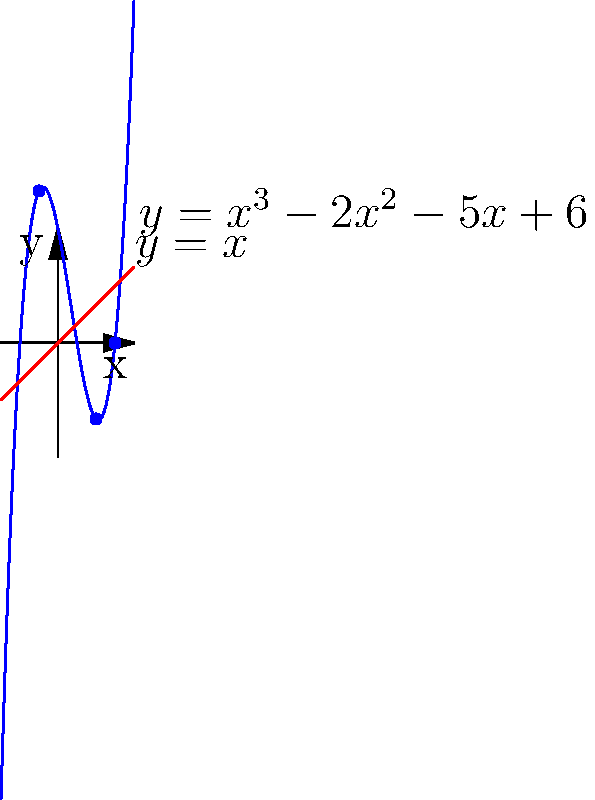Consider the polynomial $f(x) = x^3 - 2x^2 - 5x + 6$ graphed in blue, and the line $y = x$ graphed in red. Which graphical method for finding roots is represented here, and what are the approximate roots of $f(x)$? To answer this question, let's follow these steps:

1) The graphical method represented here is the intersection method. This method finds the roots of a polynomial by identifying the points where the graph of the polynomial intersects with the line $y = x$.

2) The roots of $f(x)$ are the $x$-coordinates of the points where $f(x) = x$, which are visually represented by the intersections of the blue curve (polynomial) and the red line ($y = x$).

3) From the graph, we can see three intersection points:
   - One near $x = -1$
   - One near $x = 2$
   - One near $x = 3$

4) These intersection points represent the approximate roots of the polynomial $f(x) = x^3 - 2x^2 - 5x + 6$.

5) The exact roots could be found algebraically by solving the equation $x^3 - 2x^2 - 5x + 6 = x$, or equivalently, $x^3 - 2x^2 - 6x + 6 = 0$. However, the question asks for the graphical method and approximate roots.

6) This method is particularly useful in algebraic geometry and scheme theory as it provides a visual representation of the zeros of polynomials, which correspond to points on algebraic varieties.
Answer: Intersection method; roots approximately at $x = -1, 2, 3$ 